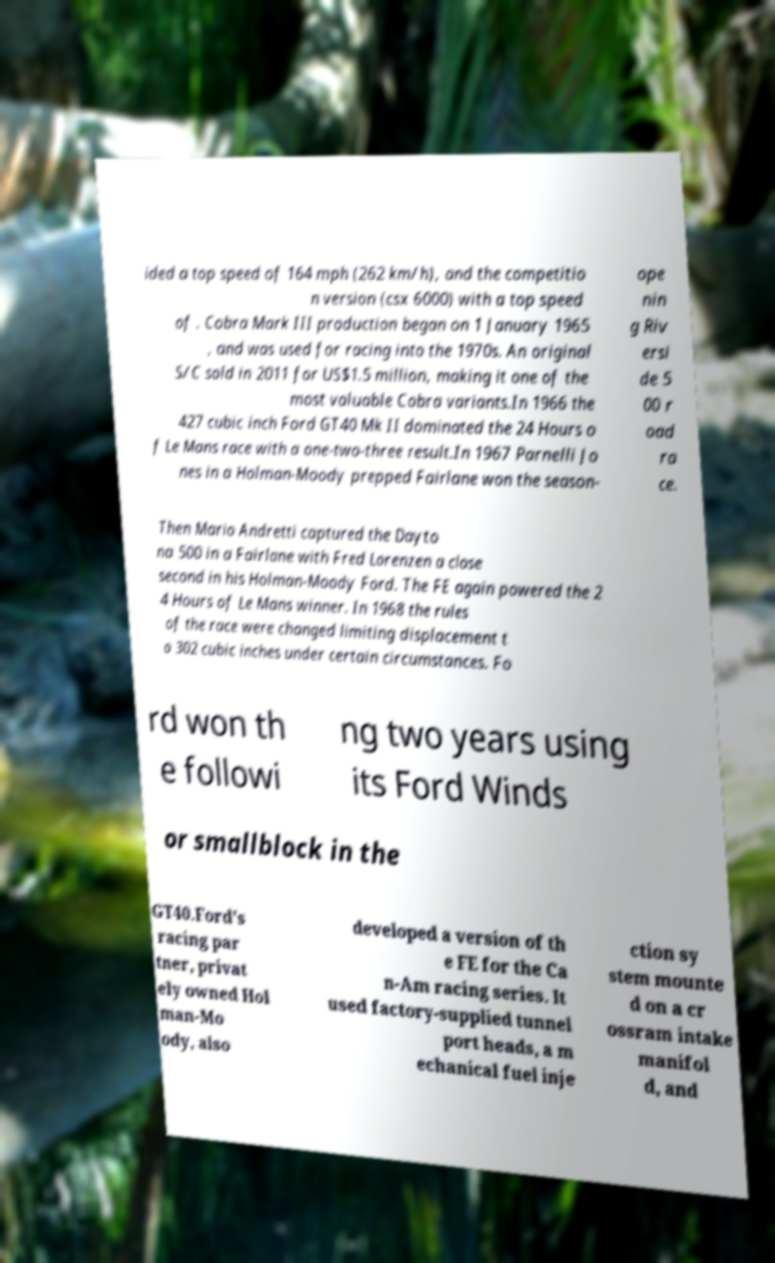For documentation purposes, I need the text within this image transcribed. Could you provide that? ided a top speed of 164 mph (262 km/h), and the competitio n version (csx 6000) with a top speed of . Cobra Mark III production began on 1 January 1965 , and was used for racing into the 1970s. An original S/C sold in 2011 for US$1.5 million, making it one of the most valuable Cobra variants.In 1966 the 427 cubic inch Ford GT40 Mk II dominated the 24 Hours o f Le Mans race with a one-two-three result.In 1967 Parnelli Jo nes in a Holman-Moody prepped Fairlane won the season- ope nin g Riv ersi de 5 00 r oad ra ce. Then Mario Andretti captured the Dayto na 500 in a Fairlane with Fred Lorenzen a close second in his Holman-Moody Ford. The FE again powered the 2 4 Hours of Le Mans winner. In 1968 the rules of the race were changed limiting displacement t o 302 cubic inches under certain circumstances. Fo rd won th e followi ng two years using its Ford Winds or smallblock in the GT40.Ford's racing par tner, privat ely owned Hol man-Mo ody, also developed a version of th e FE for the Ca n-Am racing series. It used factory-supplied tunnel port heads, a m echanical fuel inje ction sy stem mounte d on a cr ossram intake manifol d, and 